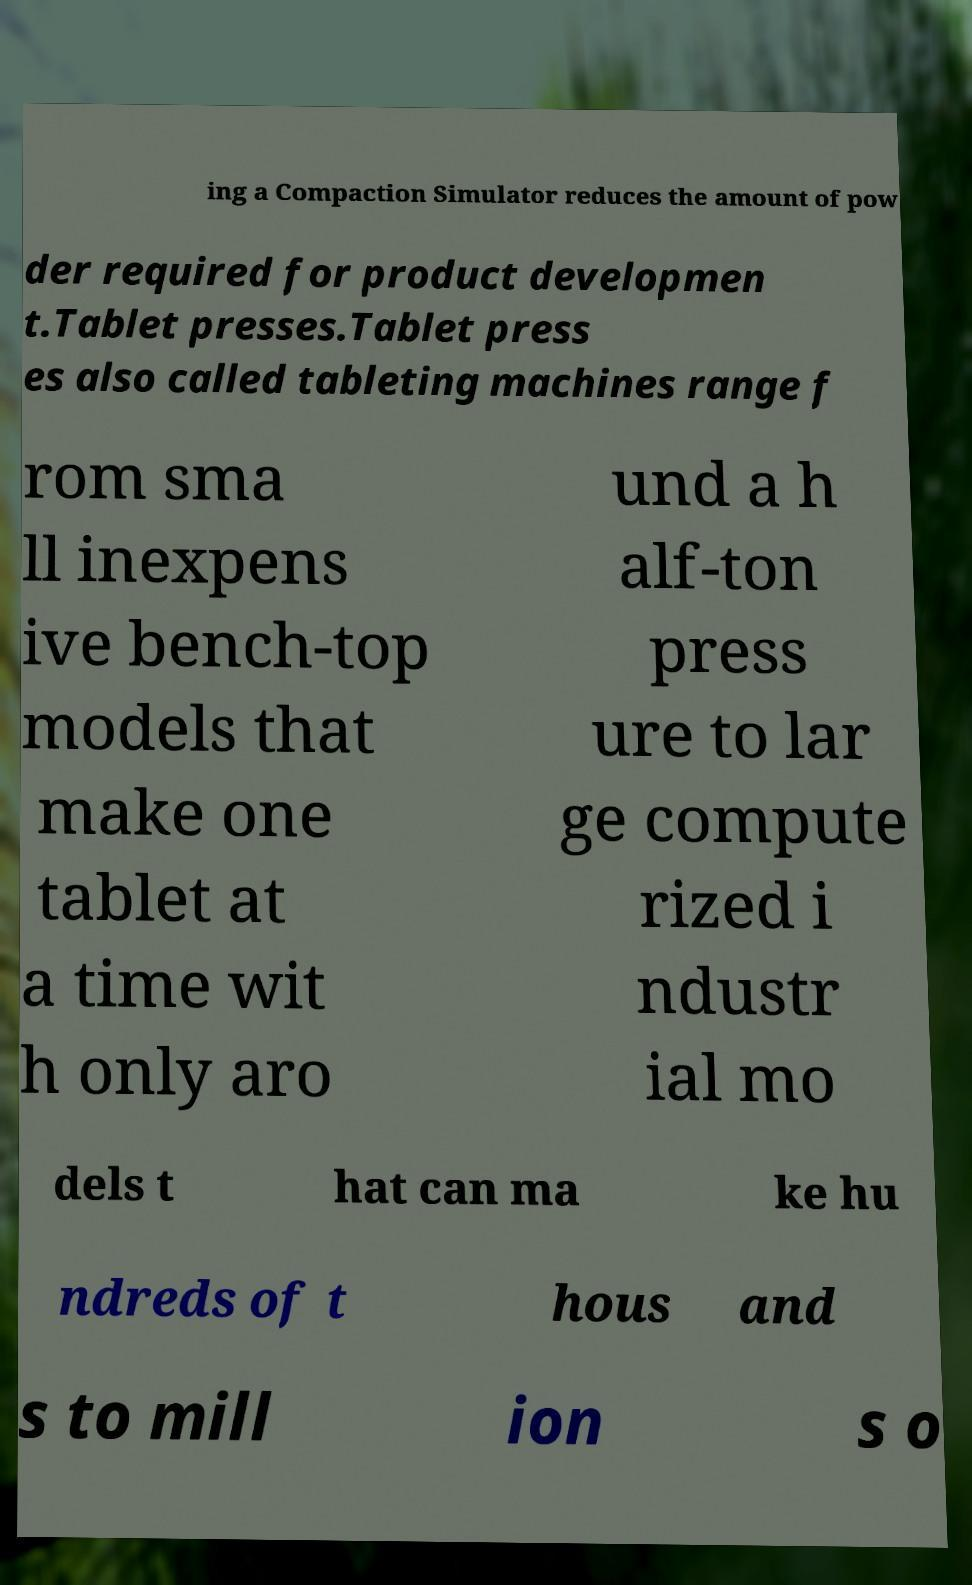Can you read and provide the text displayed in the image?This photo seems to have some interesting text. Can you extract and type it out for me? ing a Compaction Simulator reduces the amount of pow der required for product developmen t.Tablet presses.Tablet press es also called tableting machines range f rom sma ll inexpens ive bench-top models that make one tablet at a time wit h only aro und a h alf-ton press ure to lar ge compute rized i ndustr ial mo dels t hat can ma ke hu ndreds of t hous and s to mill ion s o 